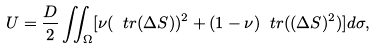Convert formula to latex. <formula><loc_0><loc_0><loc_500><loc_500>U = \frac { D } { 2 } \iint _ { \Omega } [ \nu ( \ t r ( \Delta S ) ) ^ { 2 } + ( 1 - \nu ) \ t r ( ( \Delta S ) ^ { 2 } ) ] d \sigma ,</formula> 